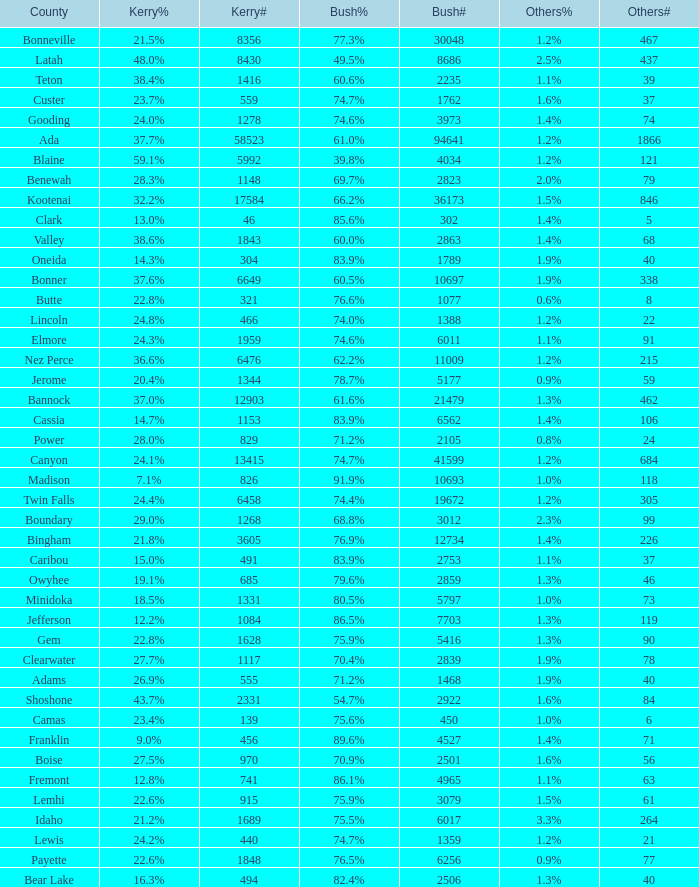What percentage of the votes were for others in the county where 462 people voted that way? 1.3%. 